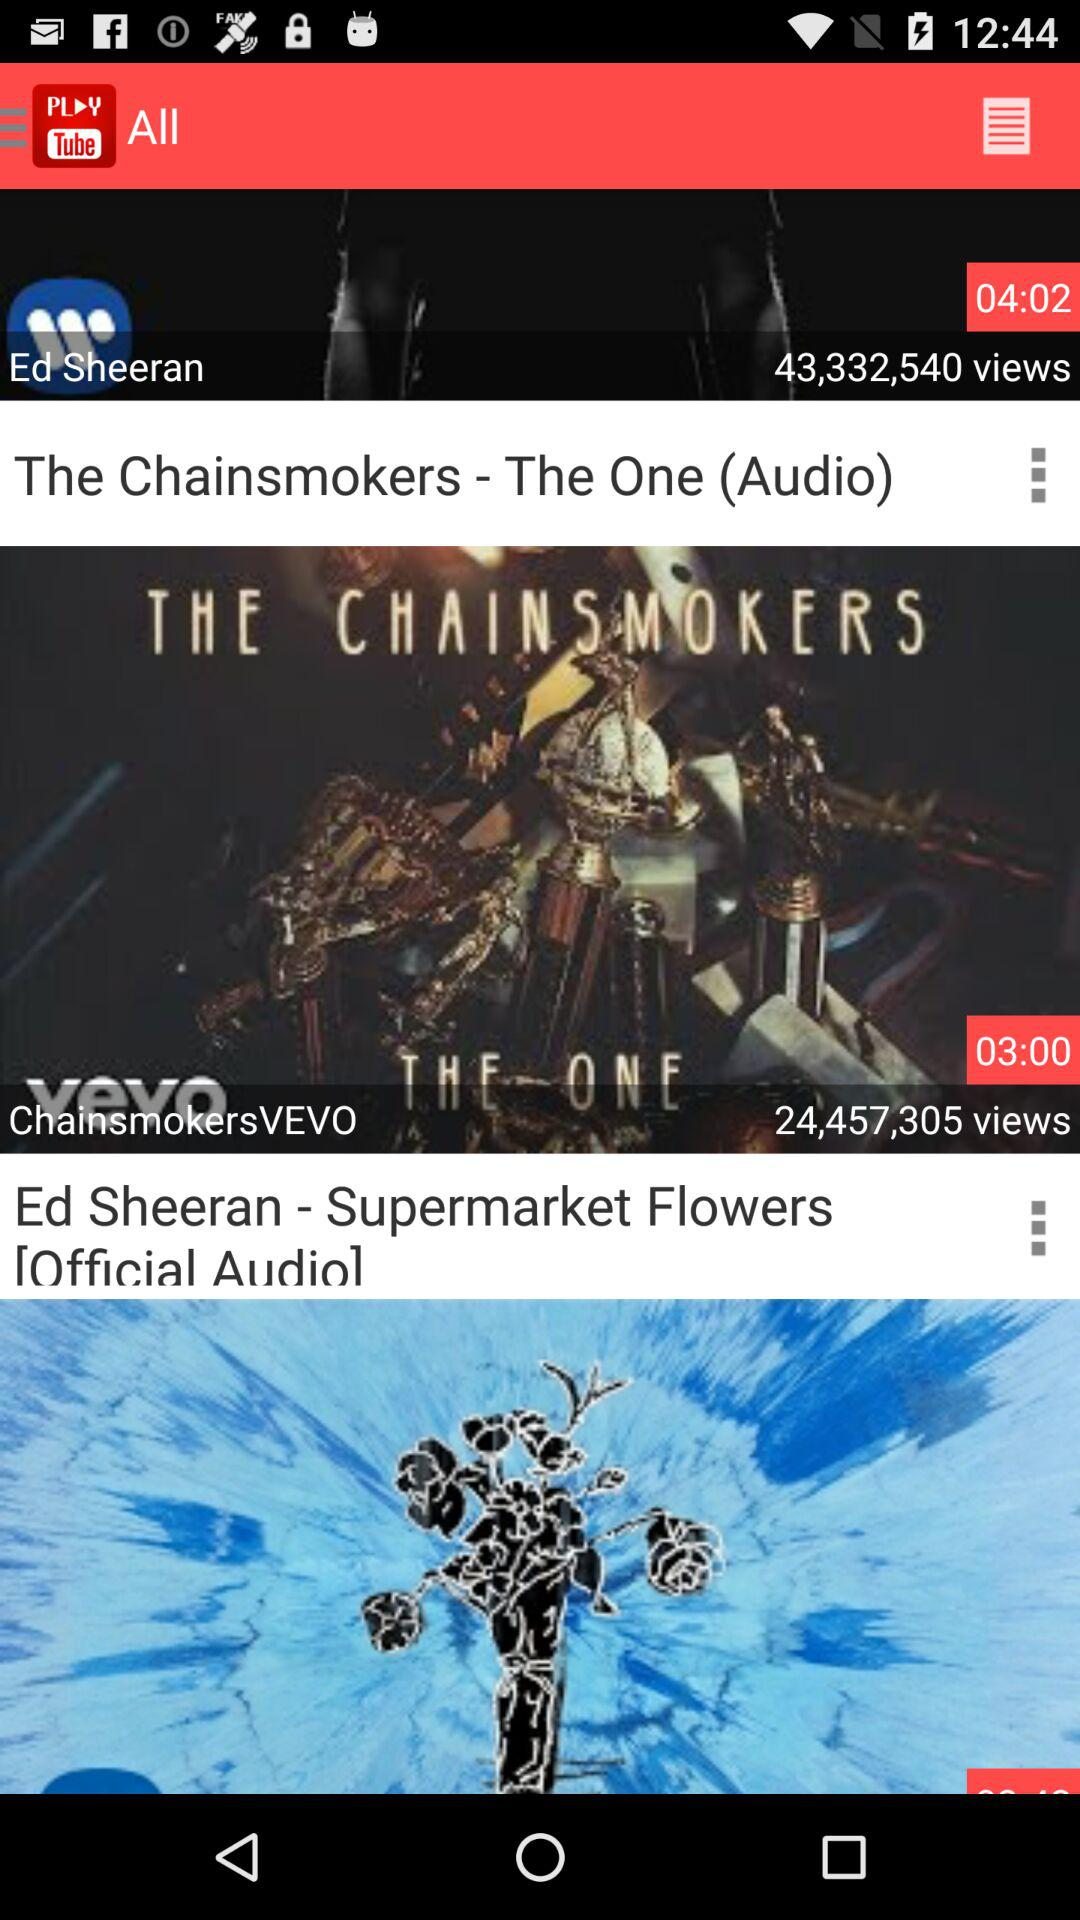What is the duration of the video posted by "ChainsmokersVEVO"? The duration of the video posted by "ChainsmokersVEVO" is 3 minutes. 